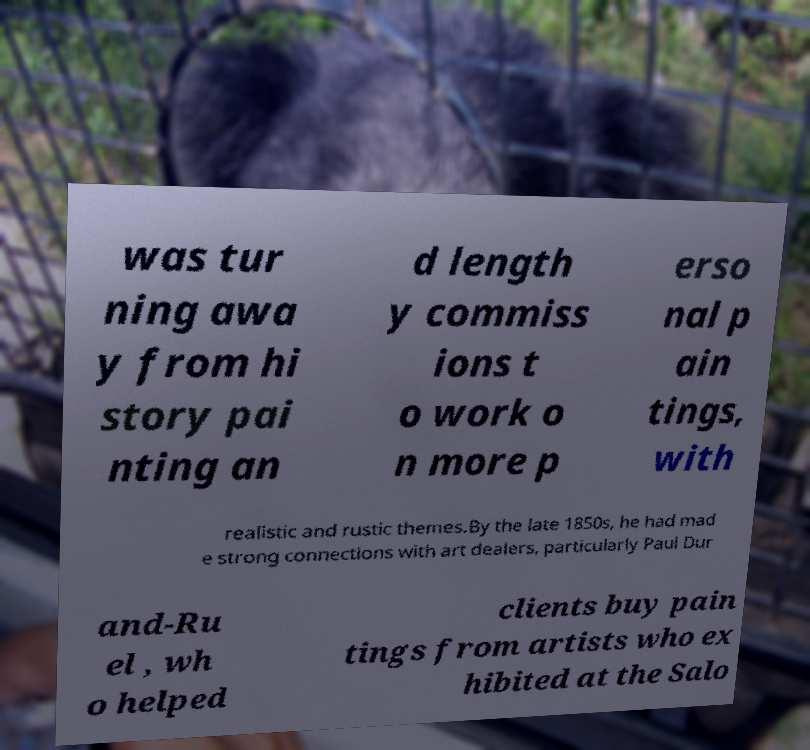Can you accurately transcribe the text from the provided image for me? was tur ning awa y from hi story pai nting an d length y commiss ions t o work o n more p erso nal p ain tings, with realistic and rustic themes.By the late 1850s, he had mad e strong connections with art dealers, particularly Paul Dur and-Ru el , wh o helped clients buy pain tings from artists who ex hibited at the Salo 